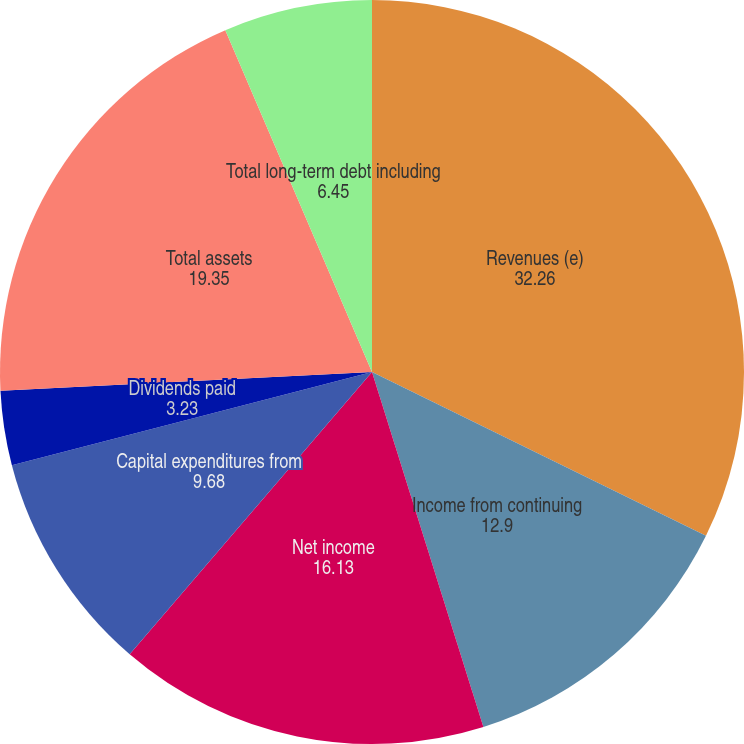Convert chart. <chart><loc_0><loc_0><loc_500><loc_500><pie_chart><fcel>Revenues (e)<fcel>Income from continuing<fcel>Net income<fcel>Capital expenditures from<fcel>Dividends paid<fcel>Dividends per share<fcel>Total assets<fcel>Total long-term debt including<nl><fcel>32.26%<fcel>12.9%<fcel>16.13%<fcel>9.68%<fcel>3.23%<fcel>0.0%<fcel>19.35%<fcel>6.45%<nl></chart> 